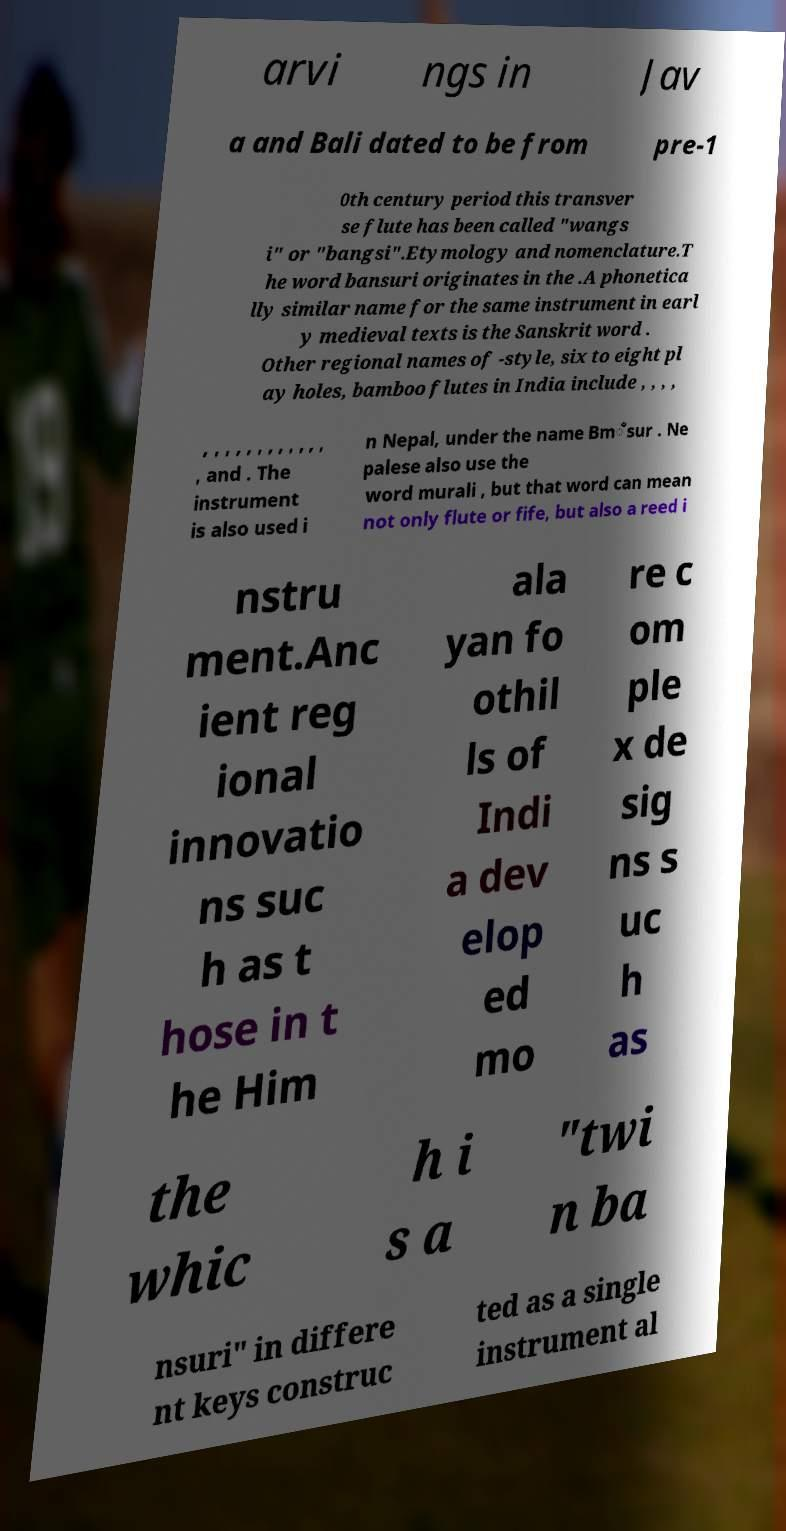I need the written content from this picture converted into text. Can you do that? arvi ngs in Jav a and Bali dated to be from pre-1 0th century period this transver se flute has been called "wangs i" or "bangsi".Etymology and nomenclature.T he word bansuri originates in the .A phonetica lly similar name for the same instrument in earl y medieval texts is the Sanskrit word . Other regional names of -style, six to eight pl ay holes, bamboo flutes in India include , , , , , , , , , , , , , , , , , and . The instrument is also used i n Nepal, under the name Bm̐sur . Ne palese also use the word murali , but that word can mean not only flute or fife, but also a reed i nstru ment.Anc ient reg ional innovatio ns suc h as t hose in t he Him ala yan fo othil ls of Indi a dev elop ed mo re c om ple x de sig ns s uc h as the whic h i s a "twi n ba nsuri" in differe nt keys construc ted as a single instrument al 